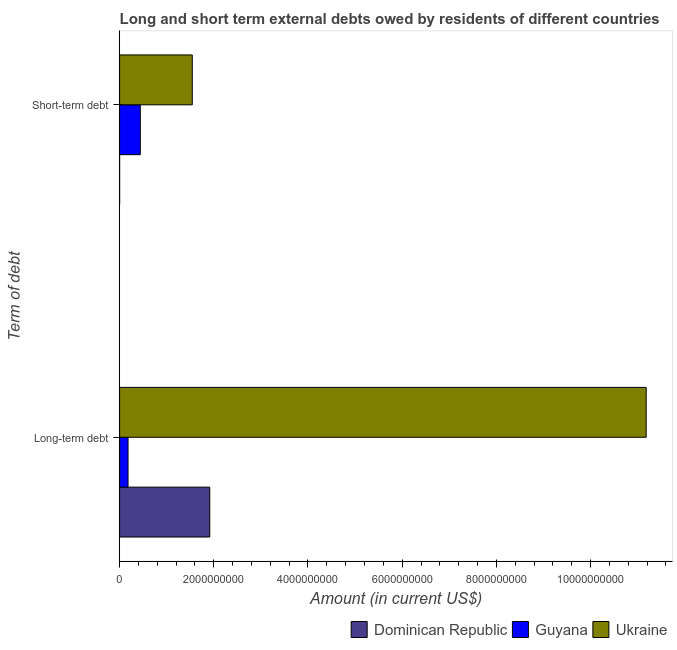How many different coloured bars are there?
Keep it short and to the point. 3. What is the label of the 1st group of bars from the top?
Keep it short and to the point. Short-term debt. Across all countries, what is the maximum long-term debts owed by residents?
Keep it short and to the point. 1.12e+1. Across all countries, what is the minimum short-term debts owed by residents?
Provide a short and direct response. 0. In which country was the long-term debts owed by residents maximum?
Your answer should be very brief. Ukraine. What is the total short-term debts owed by residents in the graph?
Offer a very short reply. 1.98e+09. What is the difference between the long-term debts owed by residents in Guyana and that in Ukraine?
Give a very brief answer. -1.10e+1. What is the difference between the long-term debts owed by residents in Ukraine and the short-term debts owed by residents in Dominican Republic?
Provide a succinct answer. 1.12e+1. What is the average long-term debts owed by residents per country?
Your response must be concise. 4.42e+09. What is the difference between the long-term debts owed by residents and short-term debts owed by residents in Guyana?
Your answer should be very brief. -2.60e+08. In how many countries, is the long-term debts owed by residents greater than 8400000000 US$?
Your response must be concise. 1. What is the ratio of the long-term debts owed by residents in Dominican Republic to that in Guyana?
Offer a terse response. 10.7. In how many countries, is the long-term debts owed by residents greater than the average long-term debts owed by residents taken over all countries?
Keep it short and to the point. 1. How many bars are there?
Your response must be concise. 5. What is the difference between two consecutive major ticks on the X-axis?
Give a very brief answer. 2.00e+09. Are the values on the major ticks of X-axis written in scientific E-notation?
Ensure brevity in your answer.  No. Does the graph contain grids?
Offer a terse response. No. Where does the legend appear in the graph?
Your answer should be compact. Bottom right. What is the title of the graph?
Give a very brief answer. Long and short term external debts owed by residents of different countries. What is the label or title of the X-axis?
Provide a succinct answer. Amount (in current US$). What is the label or title of the Y-axis?
Offer a terse response. Term of debt. What is the Amount (in current US$) of Dominican Republic in Long-term debt?
Offer a terse response. 1.91e+09. What is the Amount (in current US$) in Guyana in Long-term debt?
Make the answer very short. 1.79e+08. What is the Amount (in current US$) in Ukraine in Long-term debt?
Offer a terse response. 1.12e+1. What is the Amount (in current US$) in Guyana in Short-term debt?
Your response must be concise. 4.39e+08. What is the Amount (in current US$) in Ukraine in Short-term debt?
Keep it short and to the point. 1.54e+09. Across all Term of debt, what is the maximum Amount (in current US$) in Dominican Republic?
Make the answer very short. 1.91e+09. Across all Term of debt, what is the maximum Amount (in current US$) in Guyana?
Your response must be concise. 4.39e+08. Across all Term of debt, what is the maximum Amount (in current US$) of Ukraine?
Your answer should be very brief. 1.12e+1. Across all Term of debt, what is the minimum Amount (in current US$) in Dominican Republic?
Give a very brief answer. 0. Across all Term of debt, what is the minimum Amount (in current US$) of Guyana?
Offer a terse response. 1.79e+08. Across all Term of debt, what is the minimum Amount (in current US$) in Ukraine?
Offer a very short reply. 1.54e+09. What is the total Amount (in current US$) of Dominican Republic in the graph?
Make the answer very short. 1.91e+09. What is the total Amount (in current US$) in Guyana in the graph?
Your answer should be very brief. 6.18e+08. What is the total Amount (in current US$) in Ukraine in the graph?
Your answer should be very brief. 1.27e+1. What is the difference between the Amount (in current US$) of Guyana in Long-term debt and that in Short-term debt?
Offer a terse response. -2.60e+08. What is the difference between the Amount (in current US$) in Ukraine in Long-term debt and that in Short-term debt?
Your answer should be very brief. 9.64e+09. What is the difference between the Amount (in current US$) in Dominican Republic in Long-term debt and the Amount (in current US$) in Guyana in Short-term debt?
Provide a short and direct response. 1.47e+09. What is the difference between the Amount (in current US$) of Dominican Republic in Long-term debt and the Amount (in current US$) of Ukraine in Short-term debt?
Provide a short and direct response. 3.71e+08. What is the difference between the Amount (in current US$) of Guyana in Long-term debt and the Amount (in current US$) of Ukraine in Short-term debt?
Provide a short and direct response. -1.36e+09. What is the average Amount (in current US$) in Dominican Republic per Term of debt?
Your response must be concise. 9.57e+08. What is the average Amount (in current US$) in Guyana per Term of debt?
Your answer should be compact. 3.09e+08. What is the average Amount (in current US$) of Ukraine per Term of debt?
Your answer should be very brief. 6.36e+09. What is the difference between the Amount (in current US$) of Dominican Republic and Amount (in current US$) of Guyana in Long-term debt?
Provide a succinct answer. 1.74e+09. What is the difference between the Amount (in current US$) of Dominican Republic and Amount (in current US$) of Ukraine in Long-term debt?
Provide a succinct answer. -9.27e+09. What is the difference between the Amount (in current US$) of Guyana and Amount (in current US$) of Ukraine in Long-term debt?
Ensure brevity in your answer.  -1.10e+1. What is the difference between the Amount (in current US$) in Guyana and Amount (in current US$) in Ukraine in Short-term debt?
Offer a very short reply. -1.10e+09. What is the ratio of the Amount (in current US$) of Guyana in Long-term debt to that in Short-term debt?
Make the answer very short. 0.41. What is the ratio of the Amount (in current US$) of Ukraine in Long-term debt to that in Short-term debt?
Provide a short and direct response. 7.25. What is the difference between the highest and the second highest Amount (in current US$) of Guyana?
Your answer should be very brief. 2.60e+08. What is the difference between the highest and the second highest Amount (in current US$) in Ukraine?
Give a very brief answer. 9.64e+09. What is the difference between the highest and the lowest Amount (in current US$) of Dominican Republic?
Offer a very short reply. 1.91e+09. What is the difference between the highest and the lowest Amount (in current US$) in Guyana?
Ensure brevity in your answer.  2.60e+08. What is the difference between the highest and the lowest Amount (in current US$) of Ukraine?
Your answer should be compact. 9.64e+09. 